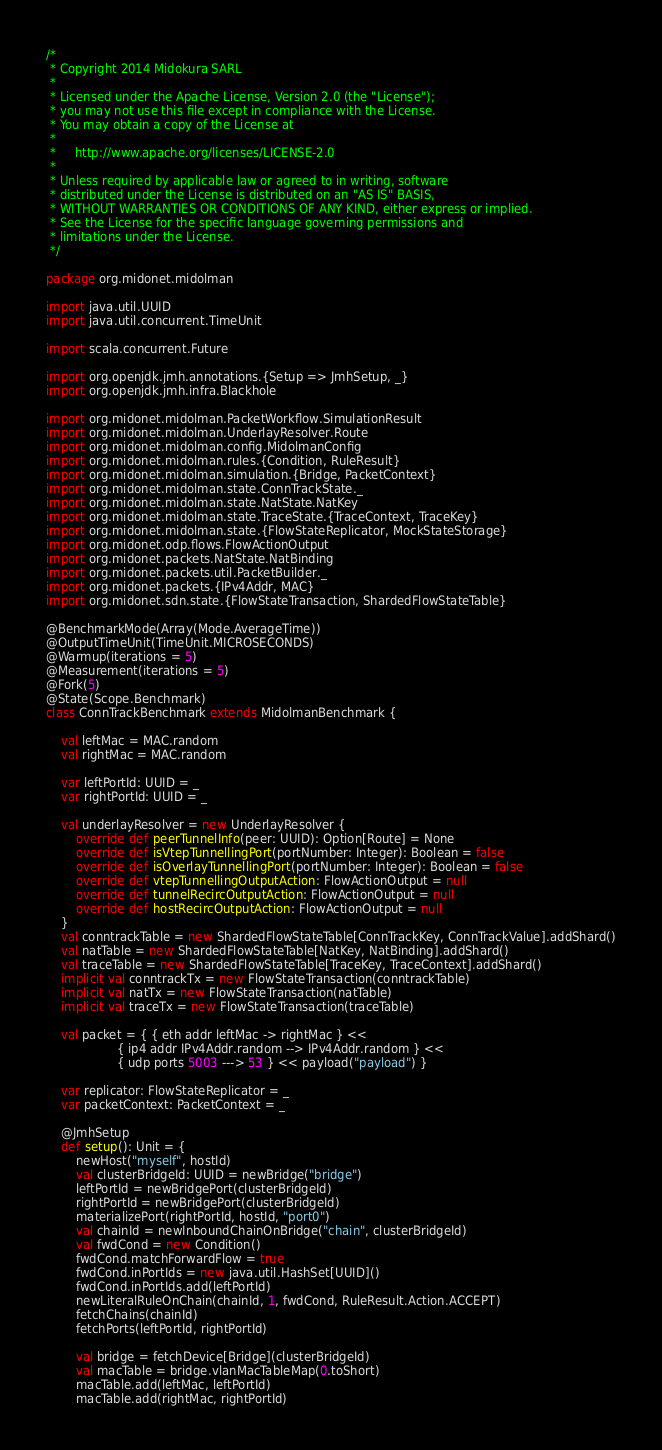Convert code to text. <code><loc_0><loc_0><loc_500><loc_500><_Scala_>/*
 * Copyright 2014 Midokura SARL
 *
 * Licensed under the Apache License, Version 2.0 (the "License");
 * you may not use this file except in compliance with the License.
 * You may obtain a copy of the License at
 *
 *     http://www.apache.org/licenses/LICENSE-2.0
 *
 * Unless required by applicable law or agreed to in writing, software
 * distributed under the License is distributed on an "AS IS" BASIS,
 * WITHOUT WARRANTIES OR CONDITIONS OF ANY KIND, either express or implied.
 * See the License for the specific language governing permissions and
 * limitations under the License.
 */

package org.midonet.midolman

import java.util.UUID
import java.util.concurrent.TimeUnit

import scala.concurrent.Future

import org.openjdk.jmh.annotations.{Setup => JmhSetup, _}
import org.openjdk.jmh.infra.Blackhole

import org.midonet.midolman.PacketWorkflow.SimulationResult
import org.midonet.midolman.UnderlayResolver.Route
import org.midonet.midolman.config.MidolmanConfig
import org.midonet.midolman.rules.{Condition, RuleResult}
import org.midonet.midolman.simulation.{Bridge, PacketContext}
import org.midonet.midolman.state.ConnTrackState._
import org.midonet.midolman.state.NatState.NatKey
import org.midonet.midolman.state.TraceState.{TraceContext, TraceKey}
import org.midonet.midolman.state.{FlowStateReplicator, MockStateStorage}
import org.midonet.odp.flows.FlowActionOutput
import org.midonet.packets.NatState.NatBinding
import org.midonet.packets.util.PacketBuilder._
import org.midonet.packets.{IPv4Addr, MAC}
import org.midonet.sdn.state.{FlowStateTransaction, ShardedFlowStateTable}

@BenchmarkMode(Array(Mode.AverageTime))
@OutputTimeUnit(TimeUnit.MICROSECONDS)
@Warmup(iterations = 5)
@Measurement(iterations = 5)
@Fork(5)
@State(Scope.Benchmark)
class ConnTrackBenchmark extends MidolmanBenchmark {

    val leftMac = MAC.random
    val rightMac = MAC.random

    var leftPortId: UUID = _
    var rightPortId: UUID = _

    val underlayResolver = new UnderlayResolver {
        override def peerTunnelInfo(peer: UUID): Option[Route] = None
        override def isVtepTunnellingPort(portNumber: Integer): Boolean = false
        override def isOverlayTunnellingPort(portNumber: Integer): Boolean = false
        override def vtepTunnellingOutputAction: FlowActionOutput = null
        override def tunnelRecircOutputAction: FlowActionOutput = null
        override def hostRecircOutputAction: FlowActionOutput = null
    }
    val conntrackTable = new ShardedFlowStateTable[ConnTrackKey, ConnTrackValue].addShard()
    val natTable = new ShardedFlowStateTable[NatKey, NatBinding].addShard()
    val traceTable = new ShardedFlowStateTable[TraceKey, TraceContext].addShard()
    implicit val conntrackTx = new FlowStateTransaction(conntrackTable)
    implicit val natTx = new FlowStateTransaction(natTable)
    implicit val traceTx = new FlowStateTransaction(traceTable)

    val packet = { { eth addr leftMac -> rightMac } <<
                   { ip4 addr IPv4Addr.random --> IPv4Addr.random } <<
                   { udp ports 5003 ---> 53 } << payload("payload") }

    var replicator: FlowStateReplicator = _
    var packetContext: PacketContext = _

    @JmhSetup
    def setup(): Unit = {
        newHost("myself", hostId)
        val clusterBridgeId: UUID = newBridge("bridge")
        leftPortId = newBridgePort(clusterBridgeId)
        rightPortId = newBridgePort(clusterBridgeId)
        materializePort(rightPortId, hostId, "port0")
        val chainId = newInboundChainOnBridge("chain", clusterBridgeId)
        val fwdCond = new Condition()
        fwdCond.matchForwardFlow = true
        fwdCond.inPortIds = new java.util.HashSet[UUID]()
        fwdCond.inPortIds.add(leftPortId)
        newLiteralRuleOnChain(chainId, 1, fwdCond, RuleResult.Action.ACCEPT)
        fetchChains(chainId)
        fetchPorts(leftPortId, rightPortId)

        val bridge = fetchDevice[Bridge](clusterBridgeId)
        val macTable = bridge.vlanMacTableMap(0.toShort)
        macTable.add(leftMac, leftPortId)
        macTable.add(rightMac, rightPortId)</code> 